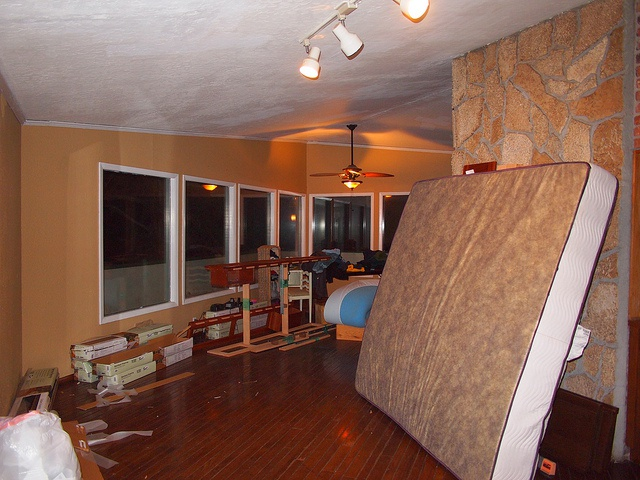Describe the objects in this image and their specific colors. I can see bed in darkgray, gray, tan, lightgray, and brown tones and chair in darkgray, maroon, gray, and tan tones in this image. 